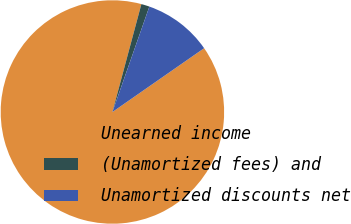<chart> <loc_0><loc_0><loc_500><loc_500><pie_chart><fcel>Unearned income<fcel>(Unamortized fees) and<fcel>Unamortized discounts net<nl><fcel>88.85%<fcel>1.19%<fcel>9.96%<nl></chart> 